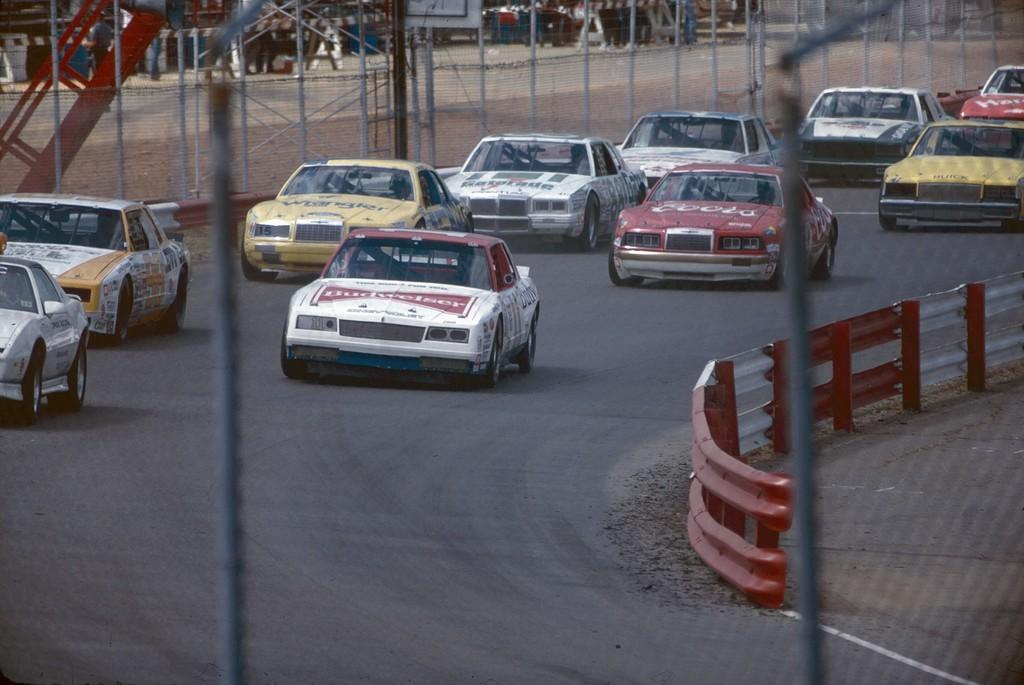What is happening on the roads in the image? There are cars on a road in the image. How many roads can be seen in the middle of the image? There are two roads in the middle of the image. What is located on the right side of the image? There is a railing on the right side of the image. What can be seen in the background of the image? There is fencing visible in the background of the image. Can you tell me how many trains are passing through the zipper in the image? There are no trains or zippers present in the image. What angle is the fencing at in the image? The angle of the fencing cannot be determined from the image, as it is not mentioned in the provided facts. 